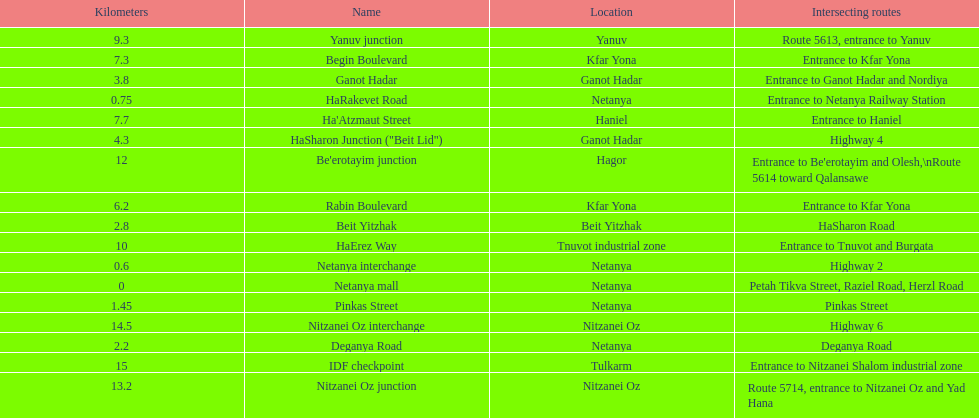How many locations in netanya are there? 5. 